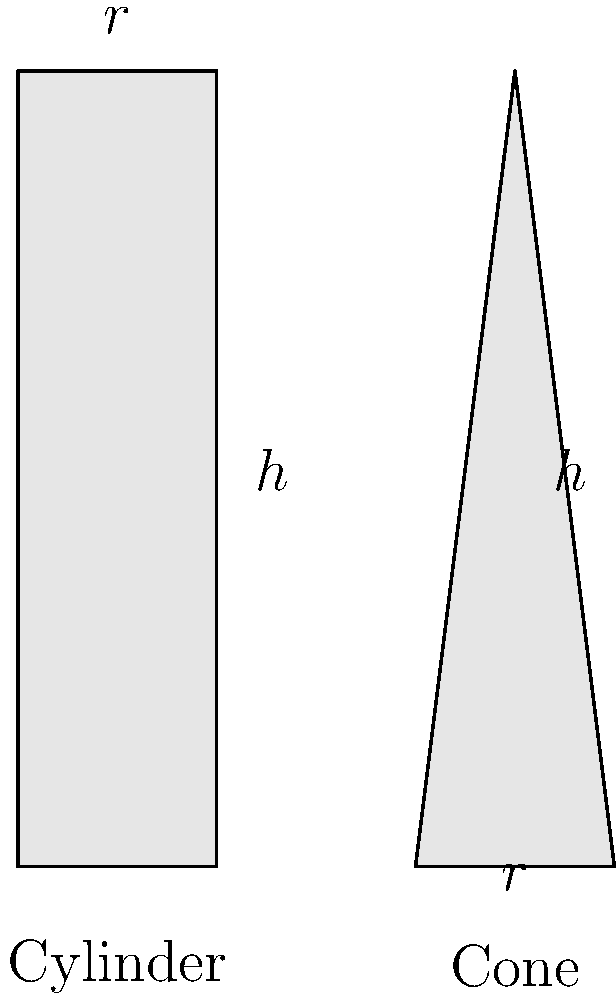As a wine expert, you're comparing the volumes of two uniquely shaped wine bottles: a cylindrical bottle and a conical bottle. Both bottles have the same height $h$ of 30 cm and base radius $r$ of 5 cm. Calculate the difference in volume between the cylindrical and conical bottles. Round your answer to the nearest whole number in cubic centimeters (cm³). Let's approach this step-by-step:

1) For the cylindrical bottle:
   Volume of a cylinder: $V_c = \pi r^2 h$
   $V_c = \pi \cdot 5^2 \cdot 30 = 750\pi$ cm³

2) For the conical bottle:
   Volume of a cone: $V_n = \frac{1}{3}\pi r^2 h$
   $V_n = \frac{1}{3} \cdot \pi \cdot 5^2 \cdot 30 = 250\pi$ cm³

3) Difference in volume:
   $\Delta V = V_c - V_n = 750\pi - 250\pi = 500\pi$ cm³

4) Converting to a numerical value:
   $500\pi \approx 1570.80$ cm³

5) Rounding to the nearest whole number:
   1571 cm³

Therefore, the cylindrical bottle can hold approximately 1571 cm³ more wine than the conical bottle.
Answer: 1571 cm³ 